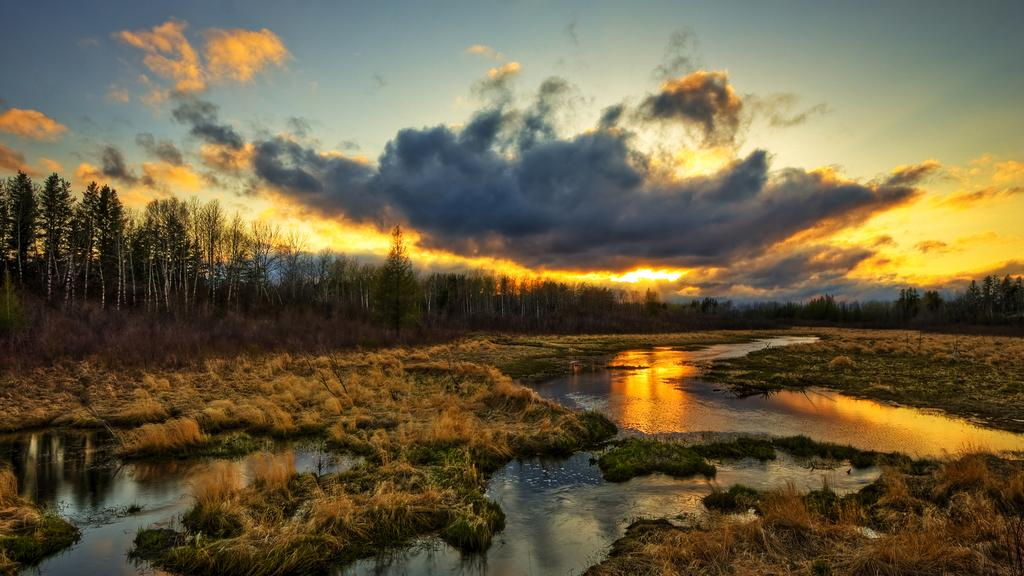What is at the bottom of the image? There is water with grass at the bottom of the image. What can be seen in the background of the image? There are trees in the background of the image. What is visible at the top of the image? The sky is visible at the top of the image. What can be observed in the sky? There are clouds and sunlight present in the sky. How many cars are parked on the grass in the image? There are no cars present in the image; it features water with grass at the bottom. Are there any beds visible in the image? There are no beds present in the image. 